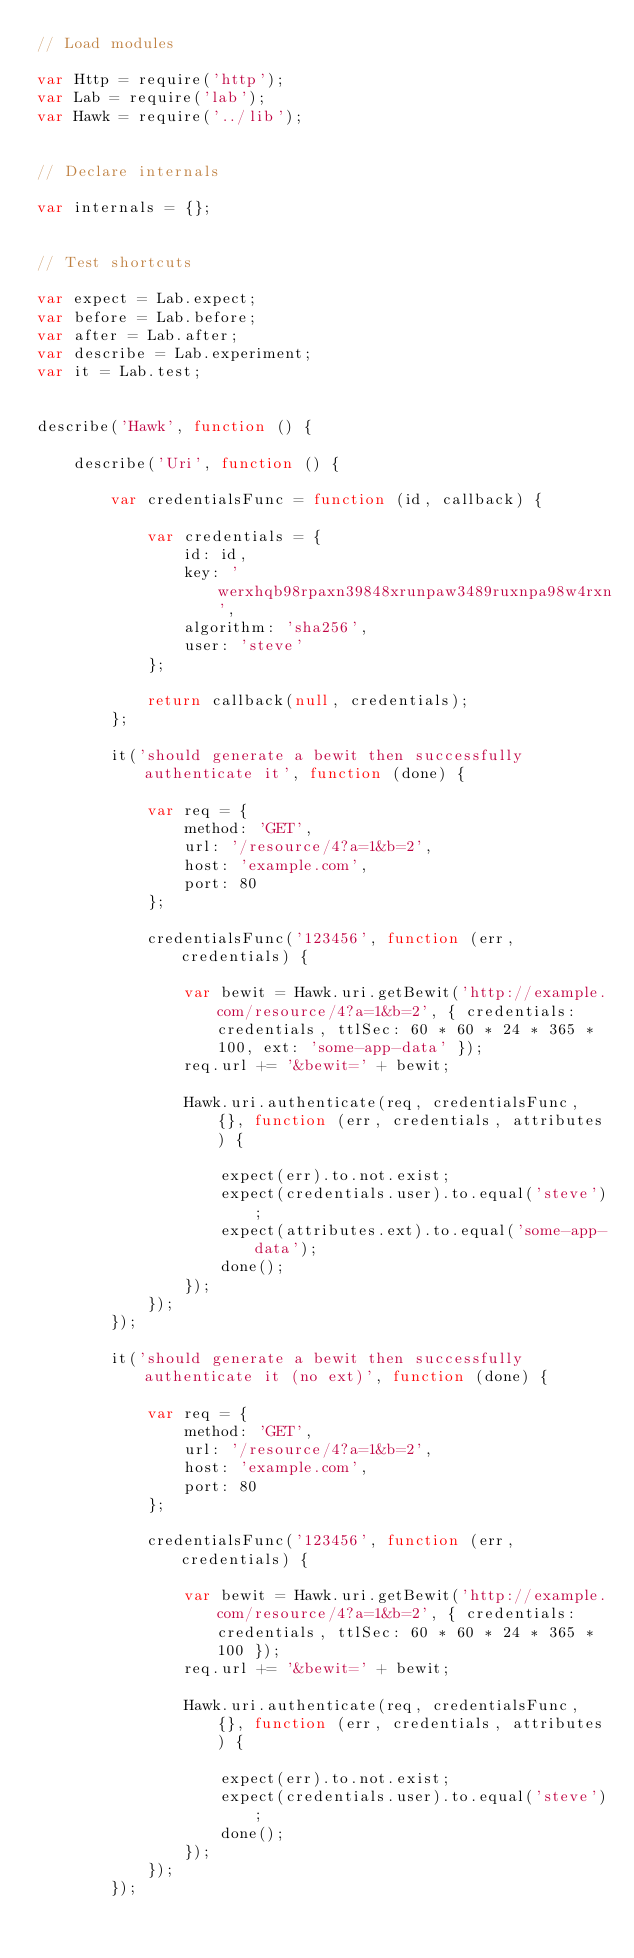Convert code to text. <code><loc_0><loc_0><loc_500><loc_500><_JavaScript_>// Load modules

var Http = require('http');
var Lab = require('lab');
var Hawk = require('../lib');


// Declare internals

var internals = {};


// Test shortcuts

var expect = Lab.expect;
var before = Lab.before;
var after = Lab.after;
var describe = Lab.experiment;
var it = Lab.test;


describe('Hawk', function () {

    describe('Uri', function () {

        var credentialsFunc = function (id, callback) {

            var credentials = {
                id: id,
                key: 'werxhqb98rpaxn39848xrunpaw3489ruxnpa98w4rxn',
                algorithm: 'sha256',
                user: 'steve'
            };

            return callback(null, credentials);
        };

        it('should generate a bewit then successfully authenticate it', function (done) {

            var req = {
                method: 'GET',
                url: '/resource/4?a=1&b=2',
                host: 'example.com',
                port: 80
            };

            credentialsFunc('123456', function (err, credentials) {

                var bewit = Hawk.uri.getBewit('http://example.com/resource/4?a=1&b=2', { credentials: credentials, ttlSec: 60 * 60 * 24 * 365 * 100, ext: 'some-app-data' });
                req.url += '&bewit=' + bewit;

                Hawk.uri.authenticate(req, credentialsFunc, {}, function (err, credentials, attributes) {

                    expect(err).to.not.exist;
                    expect(credentials.user).to.equal('steve');
                    expect(attributes.ext).to.equal('some-app-data');
                    done();
                });
            });
        });

        it('should generate a bewit then successfully authenticate it (no ext)', function (done) {

            var req = {
                method: 'GET',
                url: '/resource/4?a=1&b=2',
                host: 'example.com',
                port: 80
            };

            credentialsFunc('123456', function (err, credentials) {

                var bewit = Hawk.uri.getBewit('http://example.com/resource/4?a=1&b=2', { credentials: credentials, ttlSec: 60 * 60 * 24 * 365 * 100 });
                req.url += '&bewit=' + bewit;

                Hawk.uri.authenticate(req, credentialsFunc, {}, function (err, credentials, attributes) {

                    expect(err).to.not.exist;
                    expect(credentials.user).to.equal('steve');
                    done();
                });
            });
        });
</code> 